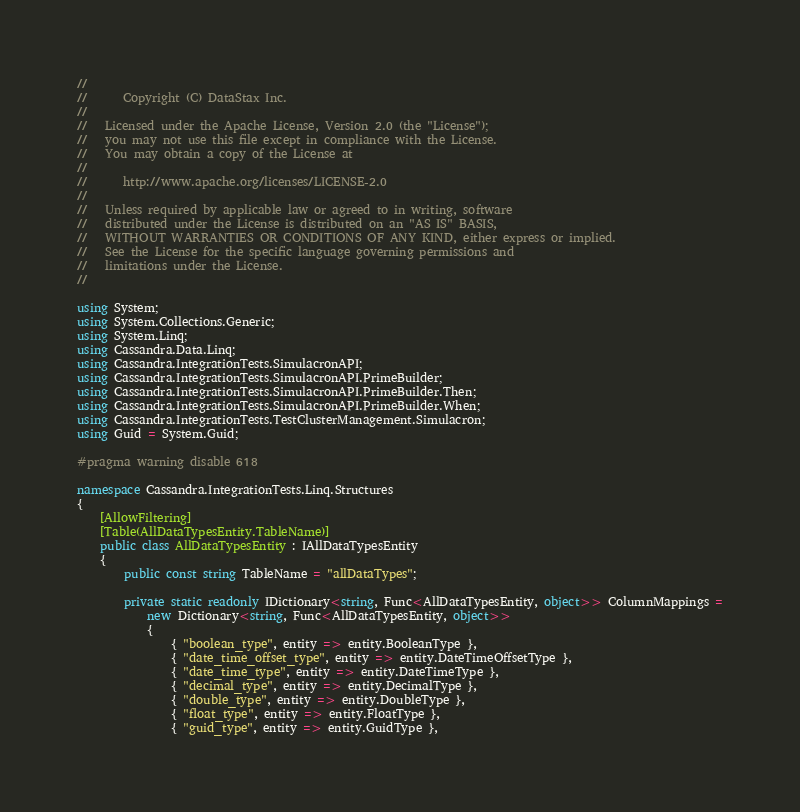<code> <loc_0><loc_0><loc_500><loc_500><_C#_>//
//      Copyright (C) DataStax Inc.
//
//   Licensed under the Apache License, Version 2.0 (the "License");
//   you may not use this file except in compliance with the License.
//   You may obtain a copy of the License at
//
//      http://www.apache.org/licenses/LICENSE-2.0
//
//   Unless required by applicable law or agreed to in writing, software
//   distributed under the License is distributed on an "AS IS" BASIS,
//   WITHOUT WARRANTIES OR CONDITIONS OF ANY KIND, either express or implied.
//   See the License for the specific language governing permissions and
//   limitations under the License.
//

using System;
using System.Collections.Generic;
using System.Linq;
using Cassandra.Data.Linq;
using Cassandra.IntegrationTests.SimulacronAPI;
using Cassandra.IntegrationTests.SimulacronAPI.PrimeBuilder;
using Cassandra.IntegrationTests.SimulacronAPI.PrimeBuilder.Then;
using Cassandra.IntegrationTests.SimulacronAPI.PrimeBuilder.When;
using Cassandra.IntegrationTests.TestClusterManagement.Simulacron;
using Guid = System.Guid;

#pragma warning disable 618

namespace Cassandra.IntegrationTests.Linq.Structures
{
    [AllowFiltering]
    [Table(AllDataTypesEntity.TableName)]
    public class AllDataTypesEntity : IAllDataTypesEntity
    {
        public const string TableName = "allDataTypes";

        private static readonly IDictionary<string, Func<AllDataTypesEntity, object>> ColumnMappings =
            new Dictionary<string, Func<AllDataTypesEntity, object>>
            {
                { "boolean_type", entity => entity.BooleanType },
                { "date_time_offset_type", entity => entity.DateTimeOffsetType },
                { "date_time_type", entity => entity.DateTimeType },
                { "decimal_type", entity => entity.DecimalType },
                { "double_type", entity => entity.DoubleType },
                { "float_type", entity => entity.FloatType },
                { "guid_type", entity => entity.GuidType },</code> 